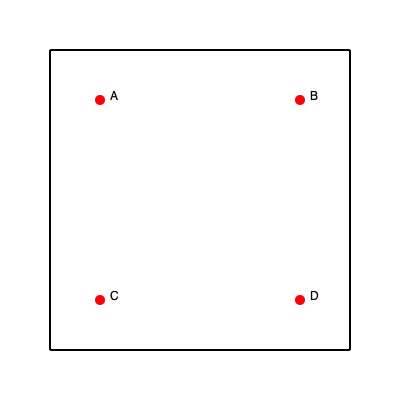As a taxi driver in a hurry, you need to pick up passengers from points A, B, C, and D in the most efficient order. Given that the city grid is 300 units by 300 units, and each point is located at the following coordinates: A(100, 100), B(300, 100), C(100, 300), and D(300, 300), what is the shortest total distance to visit all points and return to the starting point? Assume you can only drive along the grid lines. To find the shortest route, we need to consider all possible permutations of the four points and calculate the total distance for each. However, we can use some logic to reduce the number of calculations:

1. Due to the symmetry of the points, the total distance will be the same regardless of the starting point. Let's choose A as our starting and ending point.

2. The total distance will always be 1200 units (4 * 300) plus the distance between the points in the order they are visited.

3. There are three possible routes to consider:
   a. A → B → D → C → A
   b. A → C → D → B → A
   c. A → B → C → D → A (or its reverse)

4. Let's calculate the distance for each route:
   a. A → B → D → C → A:
      AB = 200, BD = 200, DC = 200, CA = 200
      Total = 1200 + 800 = 2000 units

   b. A → C → D → B → A:
      AC = 200, CD = 200, DB = 200, BA = 200
      Total = 1200 + 800 = 2000 units

   c. A → B → C → D → A:
      AB = 200, BC = 200, CD = 200, DA = 200
      Total = 1200 + 800 = 2000 units

5. All routes result in the same total distance of 2000 units.

Therefore, the shortest total distance to visit all points and return to the starting point is 2000 units.
Answer: 2000 units 